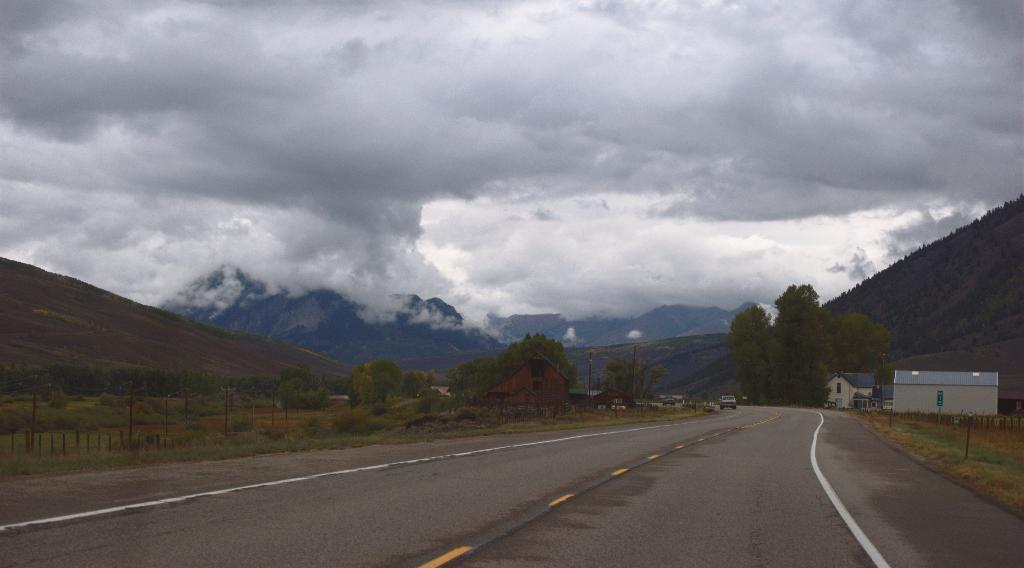What is the main feature of the image? There is a road in the image. What is happening on the road? A car is moving on the road. What type of structures can be seen in the image? There are houses in the image. What type of natural environment is visible in the image? Grasslands, trees, and hills are visible in the image. How would you describe the weather in the image? The sky in the background is cloudy. What type of agreement is being signed by the trees in the image? There are no people or agreements present in the image; it features a road, a car, houses, grasslands, trees, hills, and a cloudy sky. 